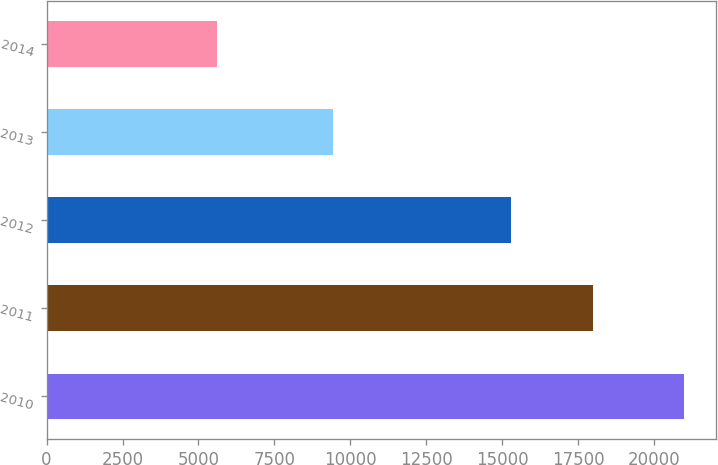<chart> <loc_0><loc_0><loc_500><loc_500><bar_chart><fcel>2010<fcel>2011<fcel>2012<fcel>2013<fcel>2014<nl><fcel>20978<fcel>18000<fcel>15275<fcel>9429<fcel>5616<nl></chart> 